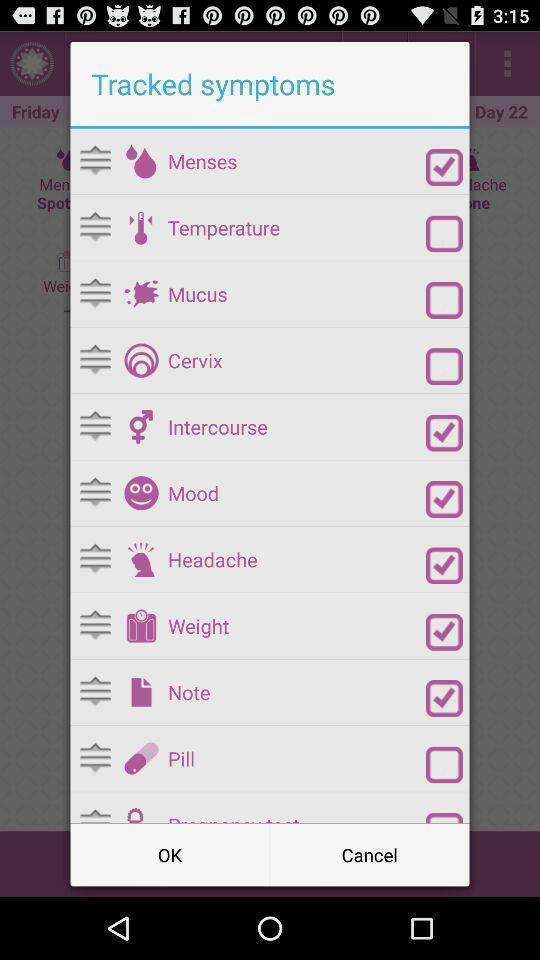Summarize the information in this screenshot. Popup to track from the list in the pregnancy app. 